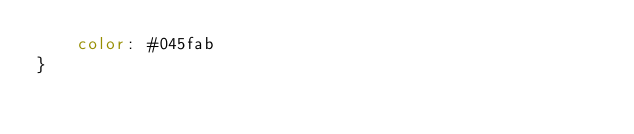Convert code to text. <code><loc_0><loc_0><loc_500><loc_500><_CSS_>    color: #045fab
}</code> 